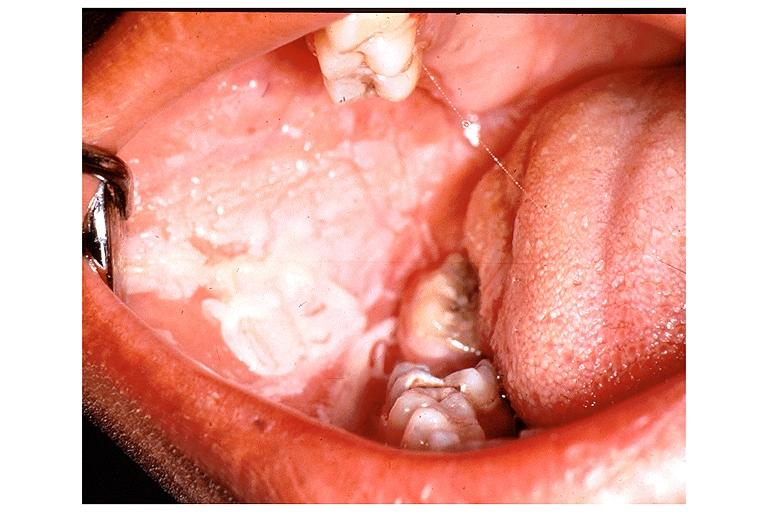does endometrial polyp show chemical burn from topical asprin?
Answer the question using a single word or phrase. No 